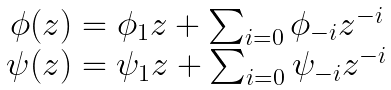Convert formula to latex. <formula><loc_0><loc_0><loc_500><loc_500>\begin{array} { c } \phi ( z ) = \phi _ { 1 } z + \sum _ { i = 0 } \phi _ { - i } z ^ { - i } \\ \psi ( z ) = \psi _ { 1 } z + \sum _ { i = 0 } \psi _ { - i } z ^ { - i } \end{array}</formula> 